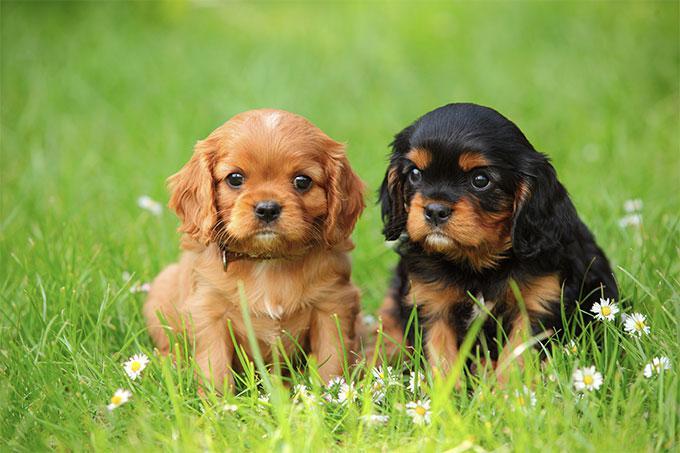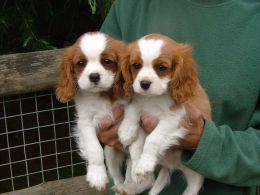The first image is the image on the left, the second image is the image on the right. Given the left and right images, does the statement "There are at most 2 puppies." hold true? Answer yes or no. No. The first image is the image on the left, the second image is the image on the right. Evaluate the accuracy of this statement regarding the images: "There are no more than two puppies.". Is it true? Answer yes or no. No. 